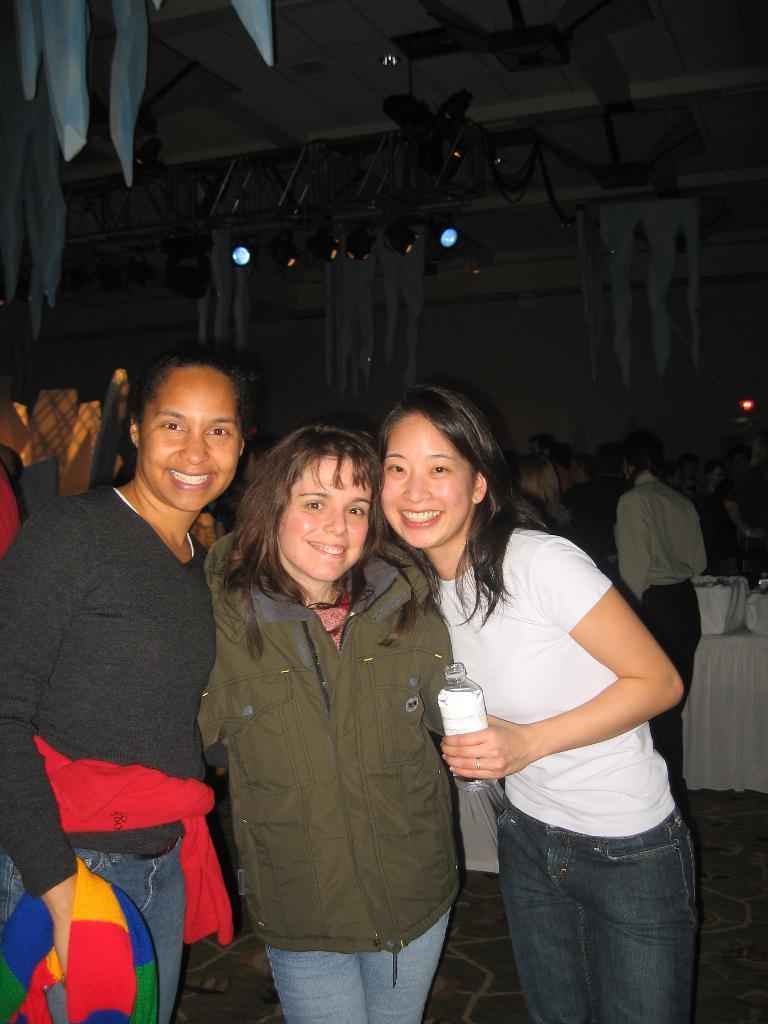How would you summarize this image in a sentence or two? In this image I can see the group of people with different color dresses. I can see one person is holding the bottle. To the right I can see some objects on the table. In the background I can see the lights and the decorative objects. 